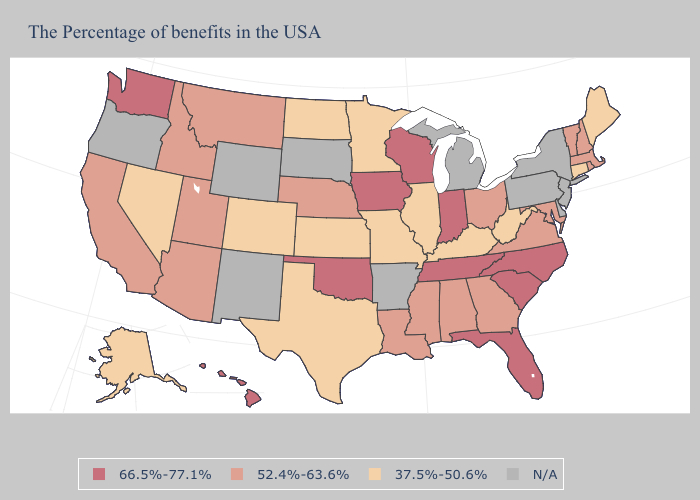Which states have the lowest value in the USA?
Be succinct. Maine, Connecticut, West Virginia, Kentucky, Illinois, Missouri, Minnesota, Kansas, Texas, North Dakota, Colorado, Nevada, Alaska. What is the lowest value in the USA?
Write a very short answer. 37.5%-50.6%. What is the highest value in states that border Indiana?
Answer briefly. 52.4%-63.6%. Name the states that have a value in the range 52.4%-63.6%?
Short answer required. Massachusetts, Rhode Island, New Hampshire, Vermont, Maryland, Virginia, Ohio, Georgia, Alabama, Mississippi, Louisiana, Nebraska, Utah, Montana, Arizona, Idaho, California. Among the states that border Arkansas , which have the lowest value?
Short answer required. Missouri, Texas. Name the states that have a value in the range N/A?
Concise answer only. New York, New Jersey, Delaware, Pennsylvania, Michigan, Arkansas, South Dakota, Wyoming, New Mexico, Oregon. Which states have the lowest value in the USA?
Short answer required. Maine, Connecticut, West Virginia, Kentucky, Illinois, Missouri, Minnesota, Kansas, Texas, North Dakota, Colorado, Nevada, Alaska. How many symbols are there in the legend?
Concise answer only. 4. Name the states that have a value in the range 37.5%-50.6%?
Short answer required. Maine, Connecticut, West Virginia, Kentucky, Illinois, Missouri, Minnesota, Kansas, Texas, North Dakota, Colorado, Nevada, Alaska. Name the states that have a value in the range N/A?
Answer briefly. New York, New Jersey, Delaware, Pennsylvania, Michigan, Arkansas, South Dakota, Wyoming, New Mexico, Oregon. Which states hav the highest value in the West?
Write a very short answer. Washington, Hawaii. What is the highest value in the USA?
Give a very brief answer. 66.5%-77.1%. What is the value of Missouri?
Short answer required. 37.5%-50.6%. 